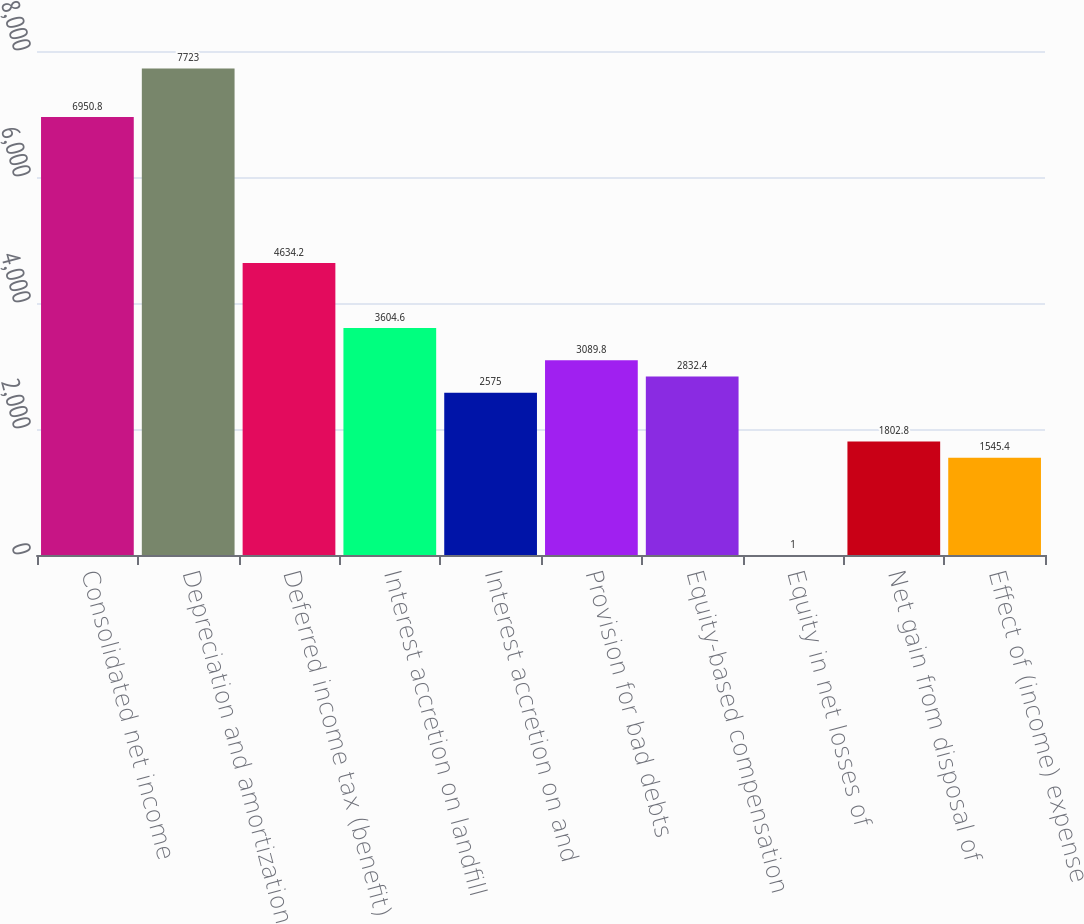Convert chart. <chart><loc_0><loc_0><loc_500><loc_500><bar_chart><fcel>Consolidated net income<fcel>Depreciation and amortization<fcel>Deferred income tax (benefit)<fcel>Interest accretion on landfill<fcel>Interest accretion on and<fcel>Provision for bad debts<fcel>Equity-based compensation<fcel>Equity in net losses of<fcel>Net gain from disposal of<fcel>Effect of (income) expense<nl><fcel>6950.8<fcel>7723<fcel>4634.2<fcel>3604.6<fcel>2575<fcel>3089.8<fcel>2832.4<fcel>1<fcel>1802.8<fcel>1545.4<nl></chart> 